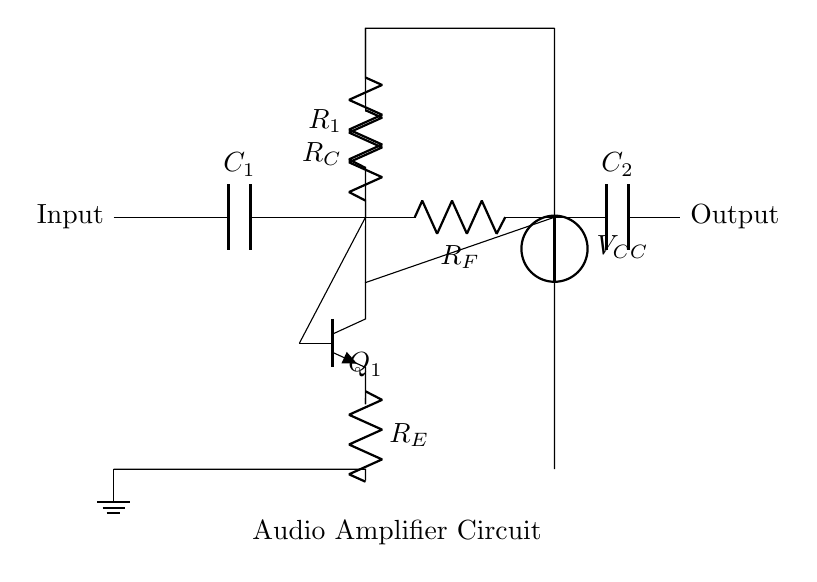What component is used for input coupling? The input coupling is done using a capacitor, labeled as C1 in the circuit diagram. Capacitors are typically used to block DC components while allowing AC signals to pass, which is essential in audio applications.
Answer: Capacitor What is the function of the transistor in this circuit? The transistor, labeled Q1 (npn), acts as an amplifier. Its function is to increase the strength of the audio signal by allowing a small input current to control a larger output current, thus enhancing sound quality for the home theater system.
Answer: Amplifier What is the role of resistor R1 in the circuit? Resistor R1 is a biasing resistor that sets the operating point of the transistor Q1, ensuring it operates in the active region for amplification. Without proper biasing, the transistor may not function effectively as an amplifier.
Answer: Biasing resistor What is the output coupling component labeled in the diagram? The output coupling is done using a capacitor, labeled as C2, which allows the amplified audio signal to pass while blocking any DC offset that the amplifier might introduce, ensuring clean output to the speakers.
Answer: Capacitor What does the symbol V_CC represent in this circuit? V_CC represents the supply voltage for the circuit. It powers various components, including the transistor, allowing them to function properly in amplifying the audio signal.
Answer: Supply voltage Which component provides feedback in the circuit? Resistor RF provides feedback by connecting the collector of the transistor back to the base. This feedback is vital for stabilizing the gain of the amplifier and ensuring linear operation.
Answer: Resistor What happens if R_E is removed from the circuit? Removing resistor R_E, which serves as an emitter resistor, would significantly increase the gain of the amplifier but at the cost of stability. This could lead to reduced linearity and possible distortion in the amplified audio signal.
Answer: Increased gain and instability 